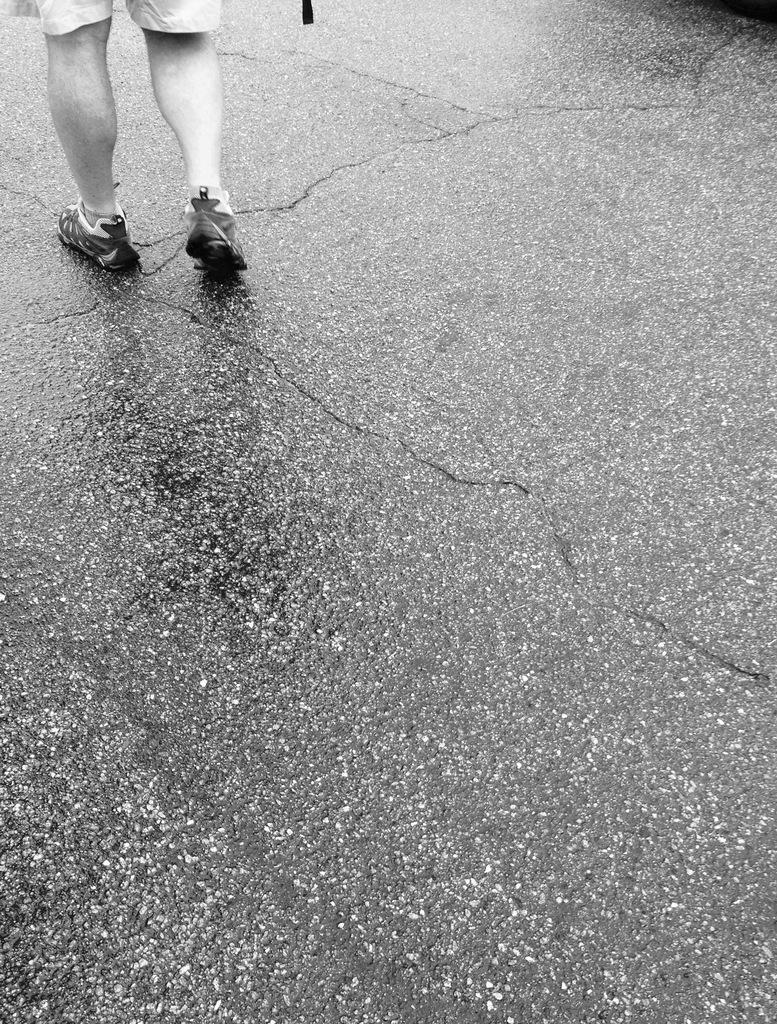What is the main subject of the image? The main subject of the image is a person standing on the road. What is the color scheme of the image? The image is black and white. What type of activity is the person engaged in at the office in the image? There is no office present in the image, and the person's activity cannot be determined from the provided facts. How does the wind affect the person's clothing in the image? There is no indication of wind or its effect on the person's clothing in the image. 